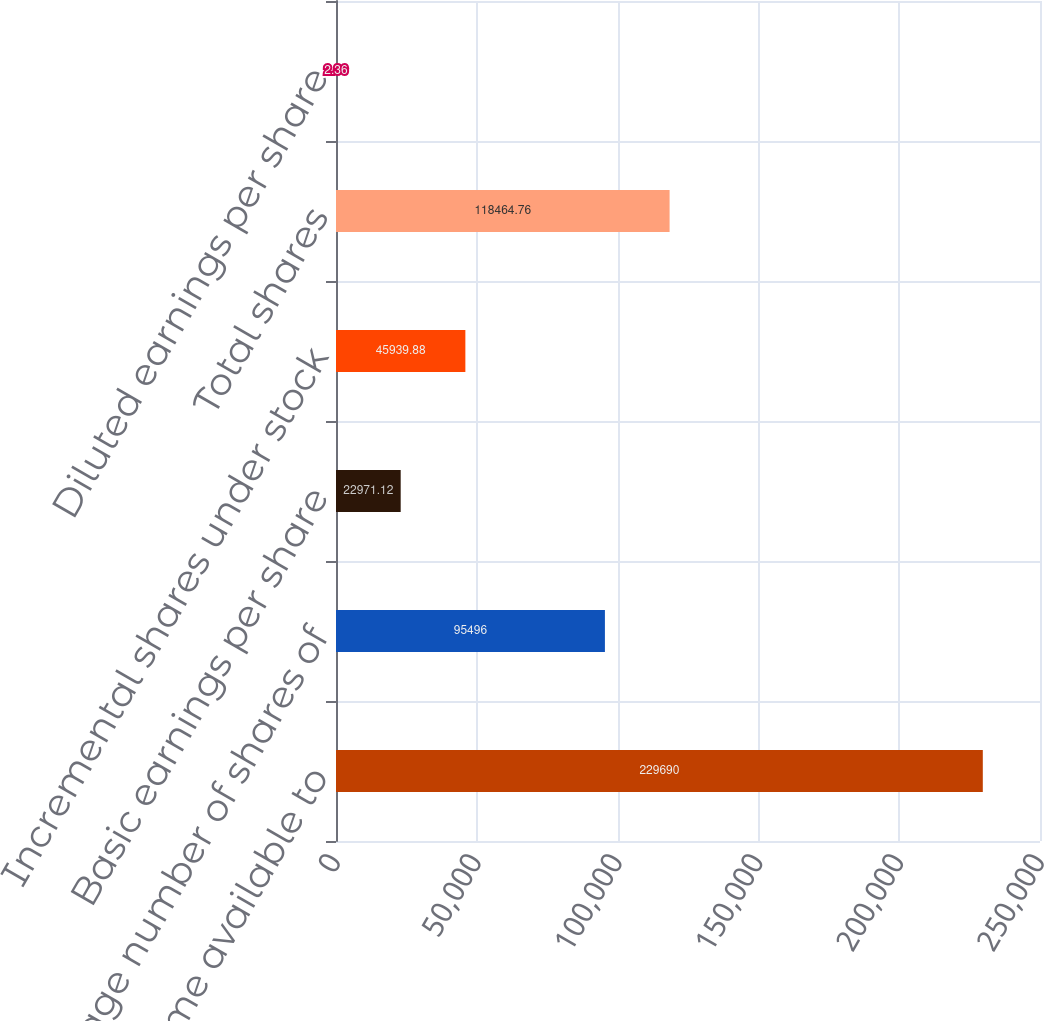Convert chart to OTSL. <chart><loc_0><loc_0><loc_500><loc_500><bar_chart><fcel>Income available to<fcel>Average number of shares of<fcel>Basic earnings per share<fcel>Incremental shares under stock<fcel>Total shares<fcel>Diluted earnings per share<nl><fcel>229690<fcel>95496<fcel>22971.1<fcel>45939.9<fcel>118465<fcel>2.36<nl></chart> 